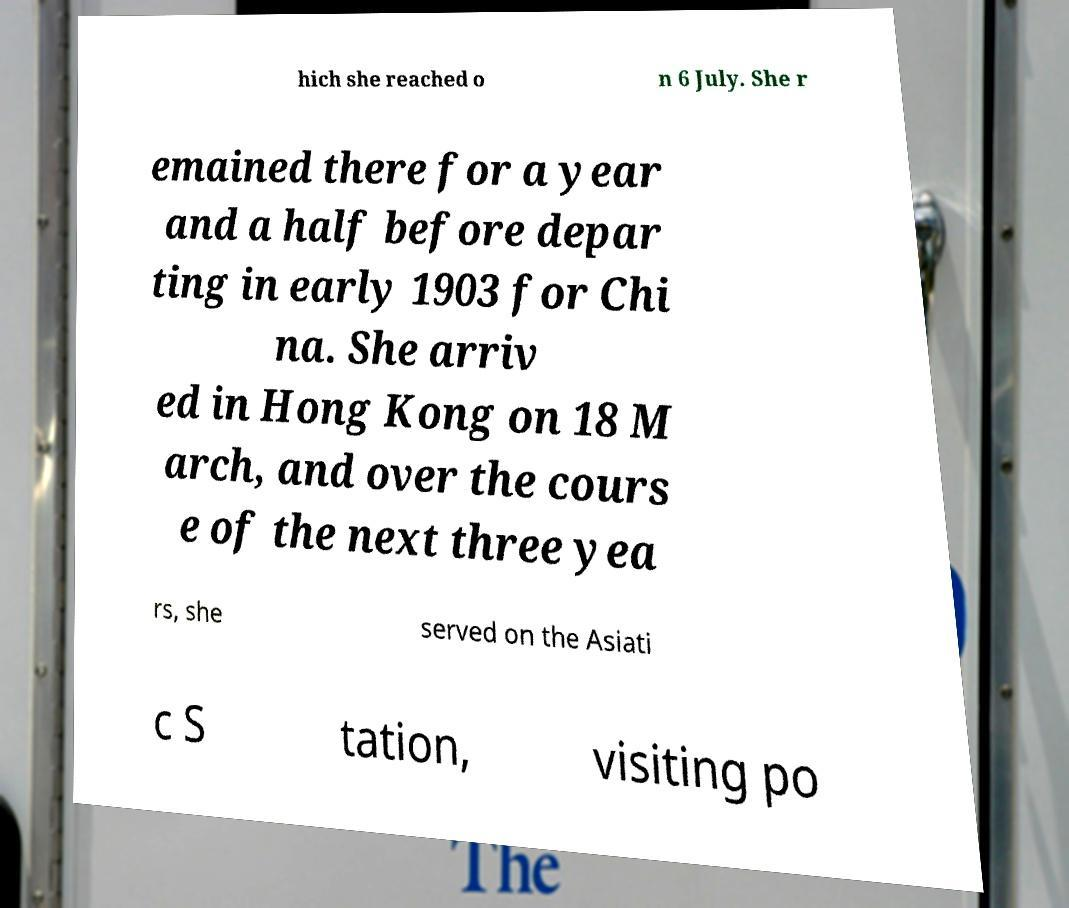What messages or text are displayed in this image? I need them in a readable, typed format. hich she reached o n 6 July. She r emained there for a year and a half before depar ting in early 1903 for Chi na. She arriv ed in Hong Kong on 18 M arch, and over the cours e of the next three yea rs, she served on the Asiati c S tation, visiting po 